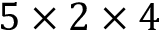Convert formula to latex. <formula><loc_0><loc_0><loc_500><loc_500>5 \times 2 \times 4</formula> 